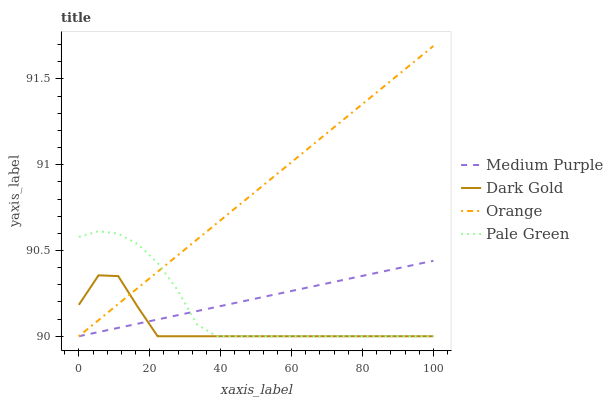Does Dark Gold have the minimum area under the curve?
Answer yes or no. Yes. Does Orange have the maximum area under the curve?
Answer yes or no. Yes. Does Pale Green have the minimum area under the curve?
Answer yes or no. No. Does Pale Green have the maximum area under the curve?
Answer yes or no. No. Is Orange the smoothest?
Answer yes or no. Yes. Is Dark Gold the roughest?
Answer yes or no. Yes. Is Pale Green the smoothest?
Answer yes or no. No. Is Pale Green the roughest?
Answer yes or no. No. Does Medium Purple have the lowest value?
Answer yes or no. Yes. Does Orange have the highest value?
Answer yes or no. Yes. Does Pale Green have the highest value?
Answer yes or no. No. Does Pale Green intersect Dark Gold?
Answer yes or no. Yes. Is Pale Green less than Dark Gold?
Answer yes or no. No. Is Pale Green greater than Dark Gold?
Answer yes or no. No. 